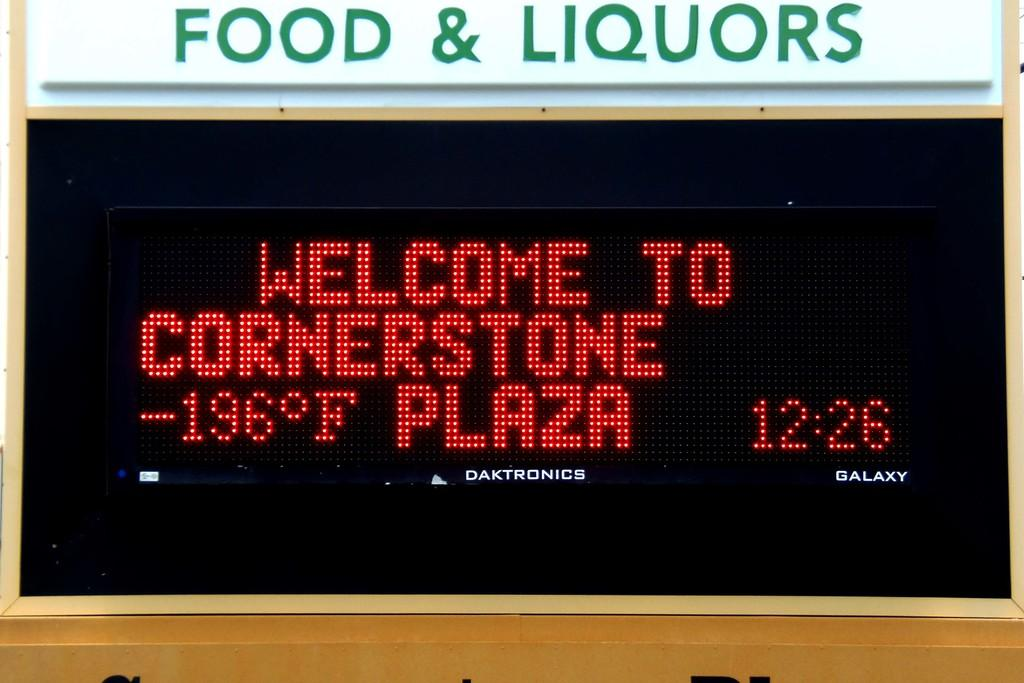<image>
Render a clear and concise summary of the photo. A banner welcoming those to Cornerstone Plaza where the time is 12:26. 